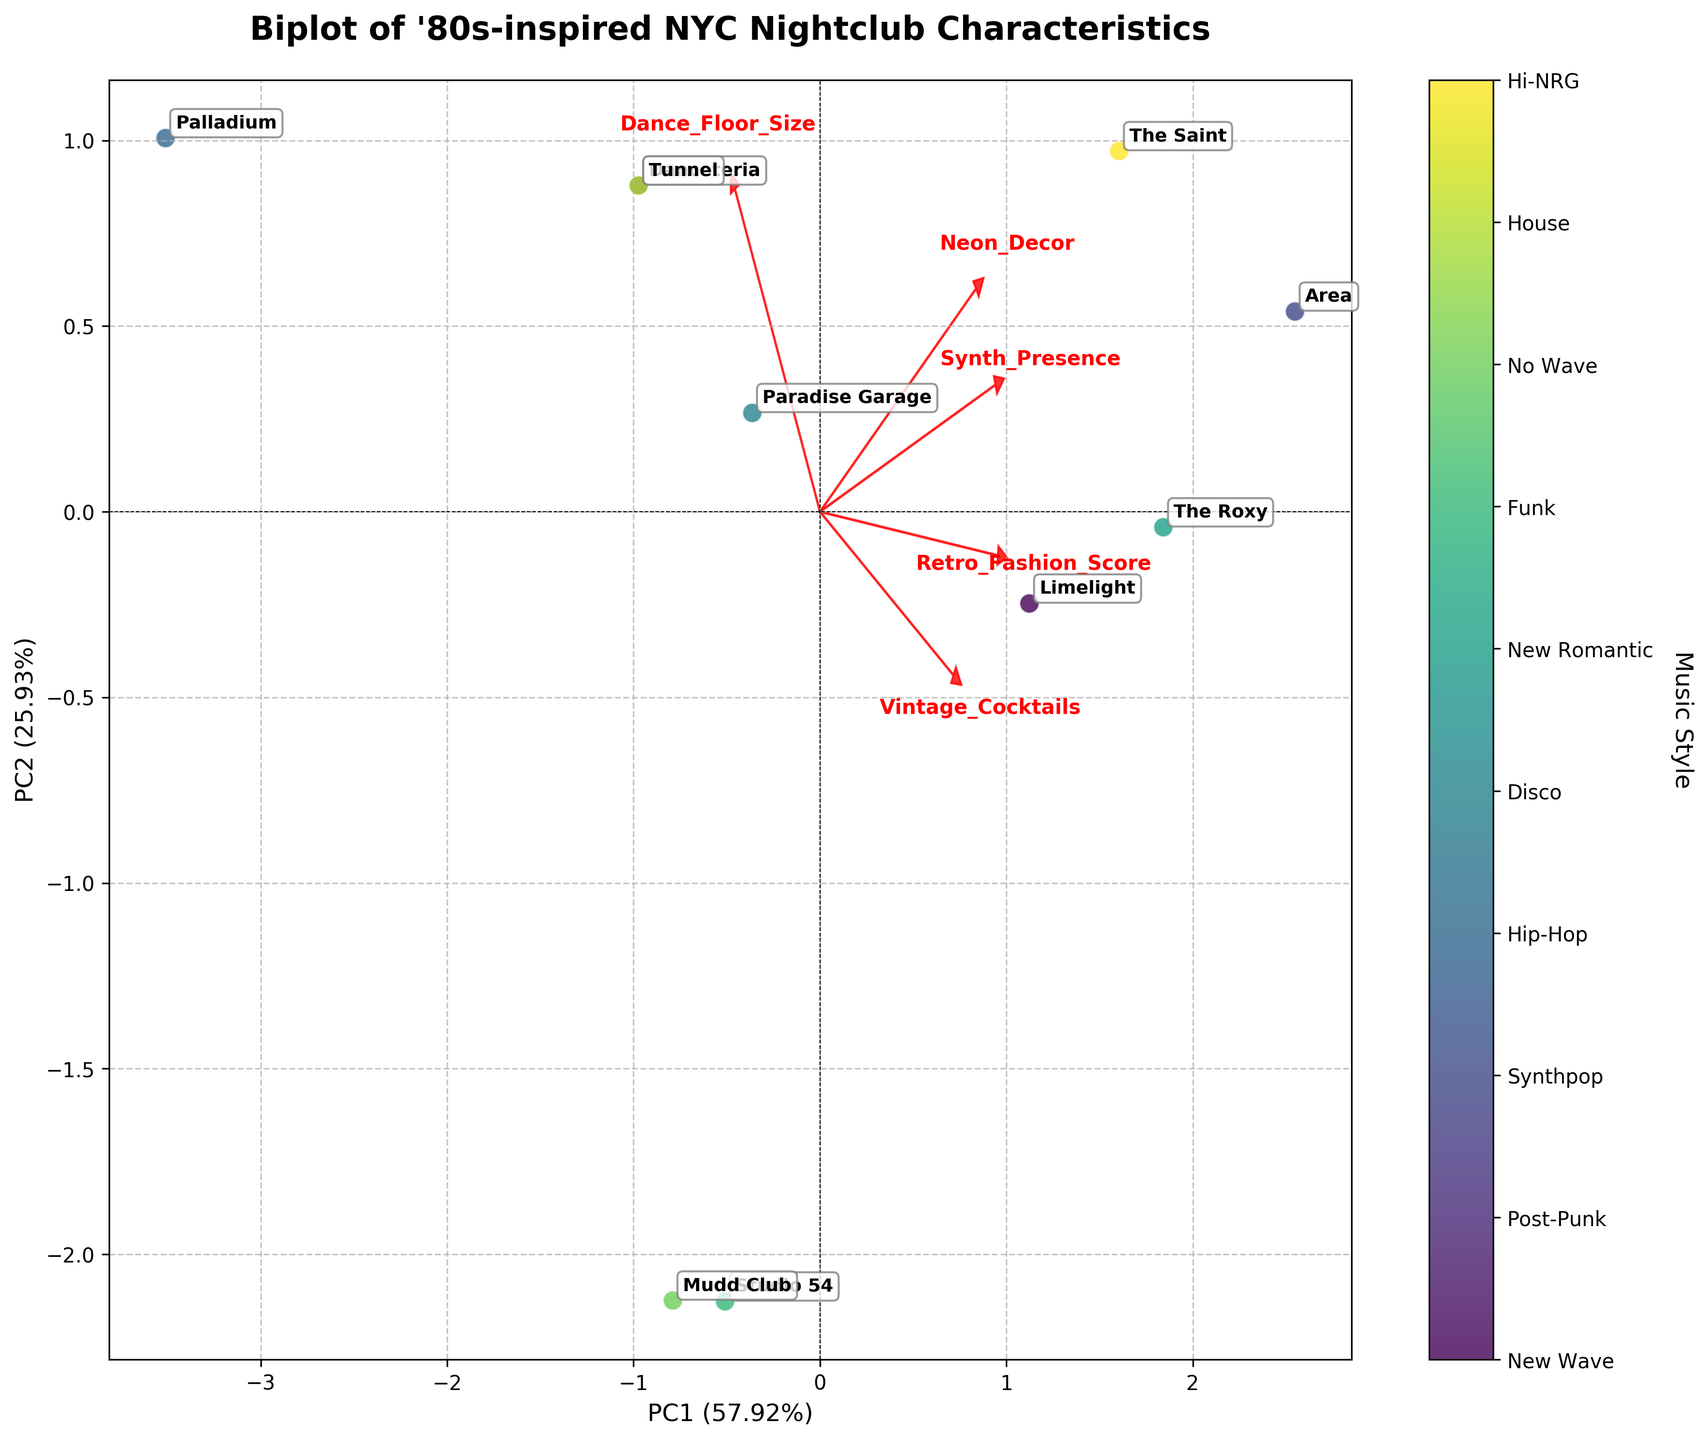How many nightclubs are depicted in the biplot? Count the number of data points or annotated labels representing each nightclub in the biplot.
Answer: 10 Which music style is represented by the nightclub that is the furthest to the right in the biplot? Identify the nightclub that has the highest value on the x-axis and check its associated music style in the legend.
Answer: House How does the 'Dance Floor Size' feature direction compare with the 'Neon Decor' feature direction? Examine the loading vectors of both features and see if their directions (arrows) are pointing similarly, oppositely, or at some angle to each other.
Answer: Similar Which nightclub has the highest 'Retro Fashion Score' according to the biplot? Look at the nightclub data point that aligns most closely with the 'Retro Fashion Score' arrow on the higher end.
Answer: Area What percentage of variance is explained by the first principal component? Read the label on the x-axis which indicates the percentage of variance explained by PC1.
Answer: 42% Which nightclub is most closely aligned with high values of 'Synth Presence' and 'Neon Decor'? Observe the data points that fall in the direction of both 'Synth Presence' and 'Neon Decor' arrows, and identify the nightclub(s) near the highest end of these vectors.
Answer: The Saint Which two features are most strongly correlated according to the loadings in the biplot? Notice which arrows are closest or point in the most similar direction, indicating strong correlation.
Answer: Synth Presence and Neon Decor Compare the 'Crowd Age' feature for 'Studio 54' and 'Paradise Garage'. Identify and compare the positions of Studio 54 and Paradise Garage on the biplot along the 'Crowd Age' loading vector.
Answer: Studio 54 has an older crowd How can you tell if 'Vintage Cocktails' influences the positioning of nightclubs on the biplot? Look at the direction and length of the 'Vintage Cocktails' loading vector to see how much it affects the data point spread. Longer arrows suggest a stronger influence.
Answer: By the influence of its loading vector 